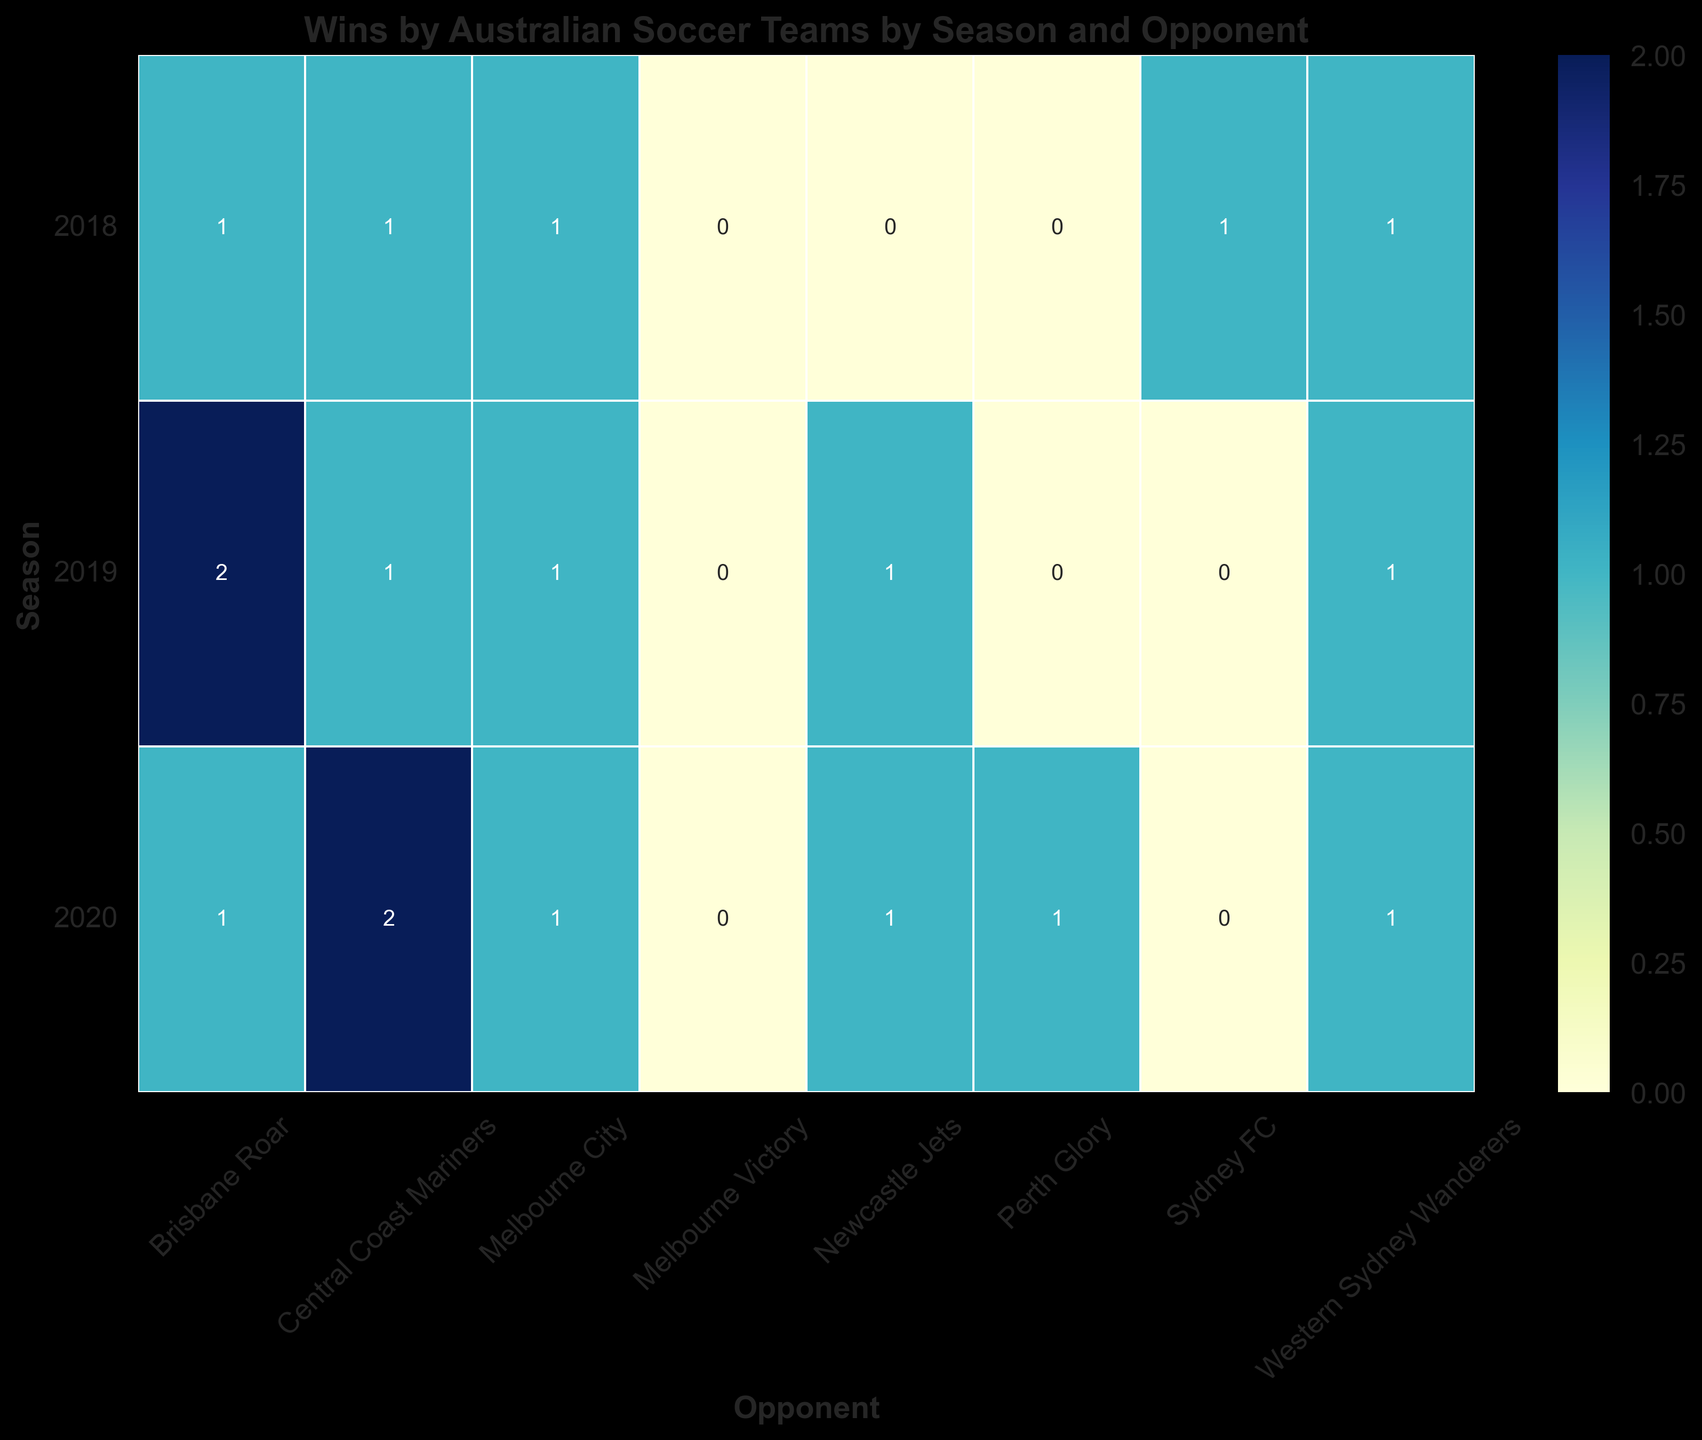Which season did the Australian soccer team have the most wins against Brisbane Roar? Look at the row of heatmap for Brisbane Roar and find the season with the highest value. The highest value of 2 is present in the year 2019.
Answer: 2019 Which opponent had the least wins against Australian soccer teams in all seasons combined? Sum up the wins across all seasons for each opponent, and compare. Perth Glory has the least wins across all seasons, with a total of 1, 0, and 1, which is 2.
Answer: Perth Glory In 2020, which opponent(s) did the Australian soccer team win against the most? Look at the 2020 row and find the cell(s) with the highest value. The highest value is 2 for Central Coast Mariners.
Answer: Central Coast Mariners How did the team's performance against Central Coast Mariners compare between the 2018 and 2020 seasons? Compare the values in the Central Coast Mariners column for 2018 and 2020. The team won 1 game in 2018 and 2 games in 2020.
Answer: Won more games in 2020 What was the total number of wins against Sydney FC from 2018 to 2020? Sum the values for Sydney FC across the 2018, 2019, and 2020 seasons. The values are 1, 0, and 0 respectively.
Answer: 1 Which season saw the highest number of wins overall for the Australian soccer team? Sum the values in each season row and compare. The highest sum is 9 in the 2019 season.
Answer: 2019 How many games did the team win against Melbourne Victory across the 2018 and 2019 seasons combined? Add the wins against Melbourne Victory for 2018 and 2019. They won 0 games in both seasons, so 0 + 0 = 0.
Answer: 0 Did the team’s performance against Newcastle Jets improve, worsen, or stay the same from 2018 to 2019? Compare the values in the Newcastle Jets column for 2018 and 2019. They won 0 games in 2018 and 1 game in 2019.
Answer: Improved How many opponents did the team win against at least once in 2020? Count the number of cells with values greater than 0 in the 2020 row. There are 5 such values.
Answer: 5 